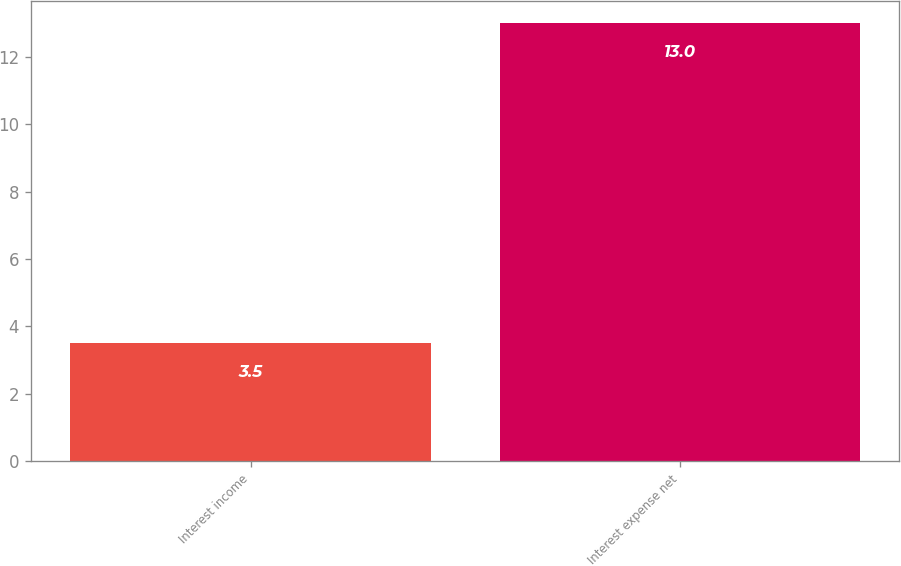Convert chart. <chart><loc_0><loc_0><loc_500><loc_500><bar_chart><fcel>Interest income<fcel>Interest expense net<nl><fcel>3.5<fcel>13<nl></chart> 